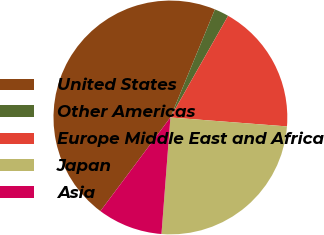Convert chart. <chart><loc_0><loc_0><loc_500><loc_500><pie_chart><fcel>United States<fcel>Other Americas<fcel>Europe Middle East and Africa<fcel>Japan<fcel>Asia<nl><fcel>46.0%<fcel>2.0%<fcel>18.0%<fcel>25.0%<fcel>9.0%<nl></chart> 